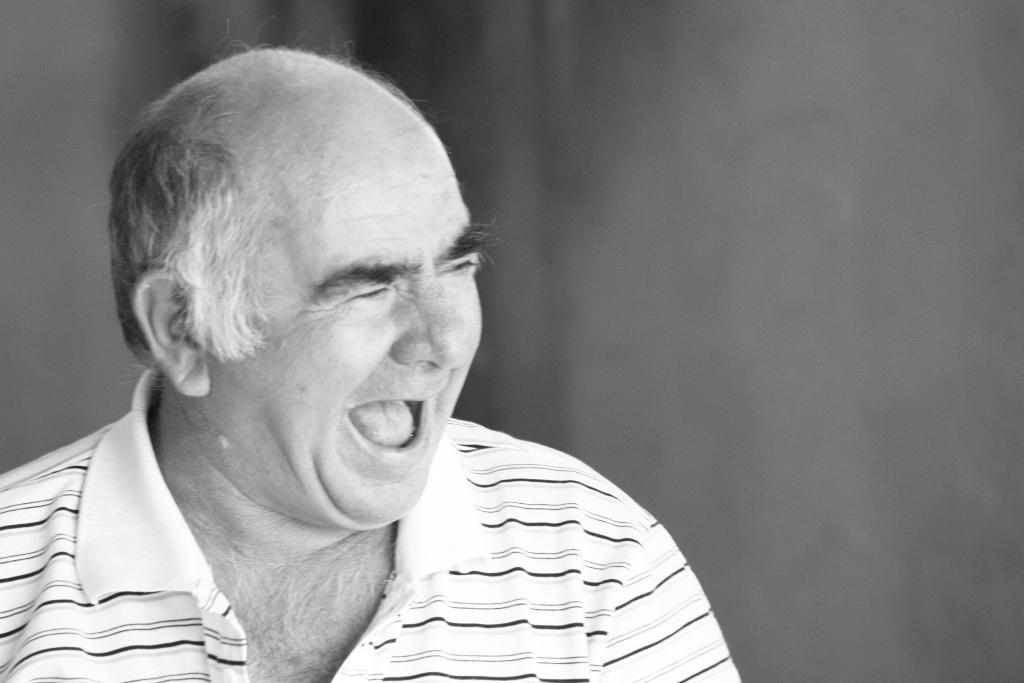Who is present in the image? There is a man in the image. Where is the man located in the image? The man is on the left side of the image. What is the man wearing in the image? The man is wearing a white t-shirt. What can be seen in the background of the image? There appears to be a wall in the background of the image. How many geese are flying over the man in the image? There are no geese present in the image. What type of flesh is visible on the man's arm in the image? There is no flesh visible on the man's arm in the image; he is wearing a white t-shirt that covers his arms. 